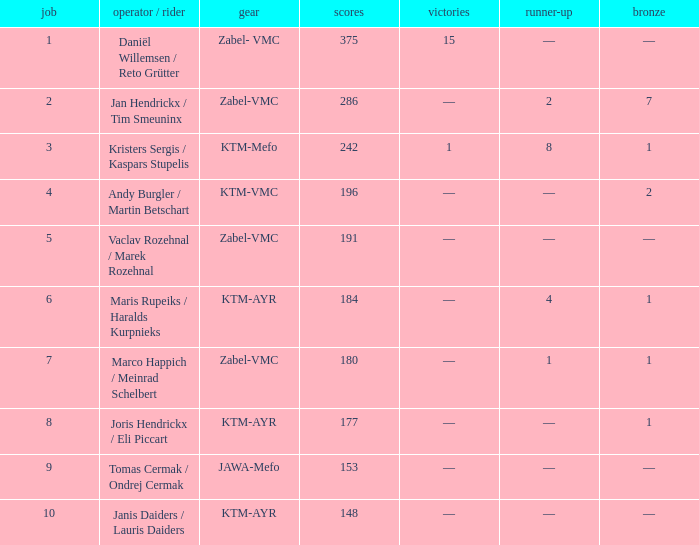What was the highest points when the second was 4? 184.0. Can you parse all the data within this table? {'header': ['job', 'operator / rider', 'gear', 'scores', 'victories', 'runner-up', 'bronze'], 'rows': [['1', 'Daniël Willemsen / Reto Grütter', 'Zabel- VMC', '375', '15', '—', '—'], ['2', 'Jan Hendrickx / Tim Smeuninx', 'Zabel-VMC', '286', '—', '2', '7'], ['3', 'Kristers Sergis / Kaspars Stupelis', 'KTM-Mefo', '242', '1', '8', '1'], ['4', 'Andy Burgler / Martin Betschart', 'KTM-VMC', '196', '—', '—', '2'], ['5', 'Vaclav Rozehnal / Marek Rozehnal', 'Zabel-VMC', '191', '—', '—', '—'], ['6', 'Maris Rupeiks / Haralds Kurpnieks', 'KTM-AYR', '184', '—', '4', '1'], ['7', 'Marco Happich / Meinrad Schelbert', 'Zabel-VMC', '180', '—', '1', '1'], ['8', 'Joris Hendrickx / Eli Piccart', 'KTM-AYR', '177', '—', '—', '1'], ['9', 'Tomas Cermak / Ondrej Cermak', 'JAWA-Mefo', '153', '—', '—', '—'], ['10', 'Janis Daiders / Lauris Daiders', 'KTM-AYR', '148', '—', '—', '—']]} 